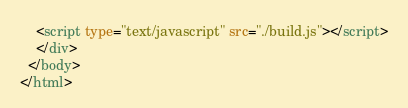<code> <loc_0><loc_0><loc_500><loc_500><_HTML_>    <script type="text/javascript" src="./build.js"></script>
    </div>
  </body>
</html></code> 